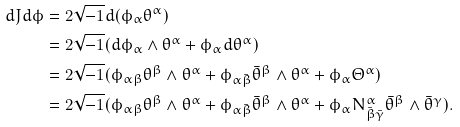Convert formula to latex. <formula><loc_0><loc_0><loc_500><loc_500>d J d \phi & = 2 \sqrt { - 1 } d ( \phi _ { \alpha } \theta ^ { \alpha } ) \\ & = 2 \sqrt { - 1 } ( d \phi _ { \alpha } \wedge \theta ^ { \alpha } + \phi _ { \alpha } d \theta ^ { \alpha } ) \\ & = 2 \sqrt { - 1 } ( \phi _ { \alpha \beta } \theta ^ { \beta } \wedge \theta ^ { \alpha } + \phi _ { \alpha \bar { \beta } } \bar { \theta } ^ { \beta } \wedge \theta ^ { \alpha } + \phi _ { \alpha } \Theta ^ { \alpha } ) \\ & = 2 \sqrt { - 1 } ( \phi _ { \alpha \beta } \theta ^ { \beta } \wedge \theta ^ { \alpha } + \phi _ { \alpha \bar { \beta } } \bar { \theta } ^ { \beta } \wedge \theta ^ { \alpha } + \phi _ { \alpha } N _ { \bar { \beta } \bar { \gamma } } ^ { \alpha } \bar { \theta } ^ { \beta } \wedge \bar { \theta } ^ { \gamma } ) .</formula> 